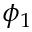Convert formula to latex. <formula><loc_0><loc_0><loc_500><loc_500>\phi _ { 1 }</formula> 